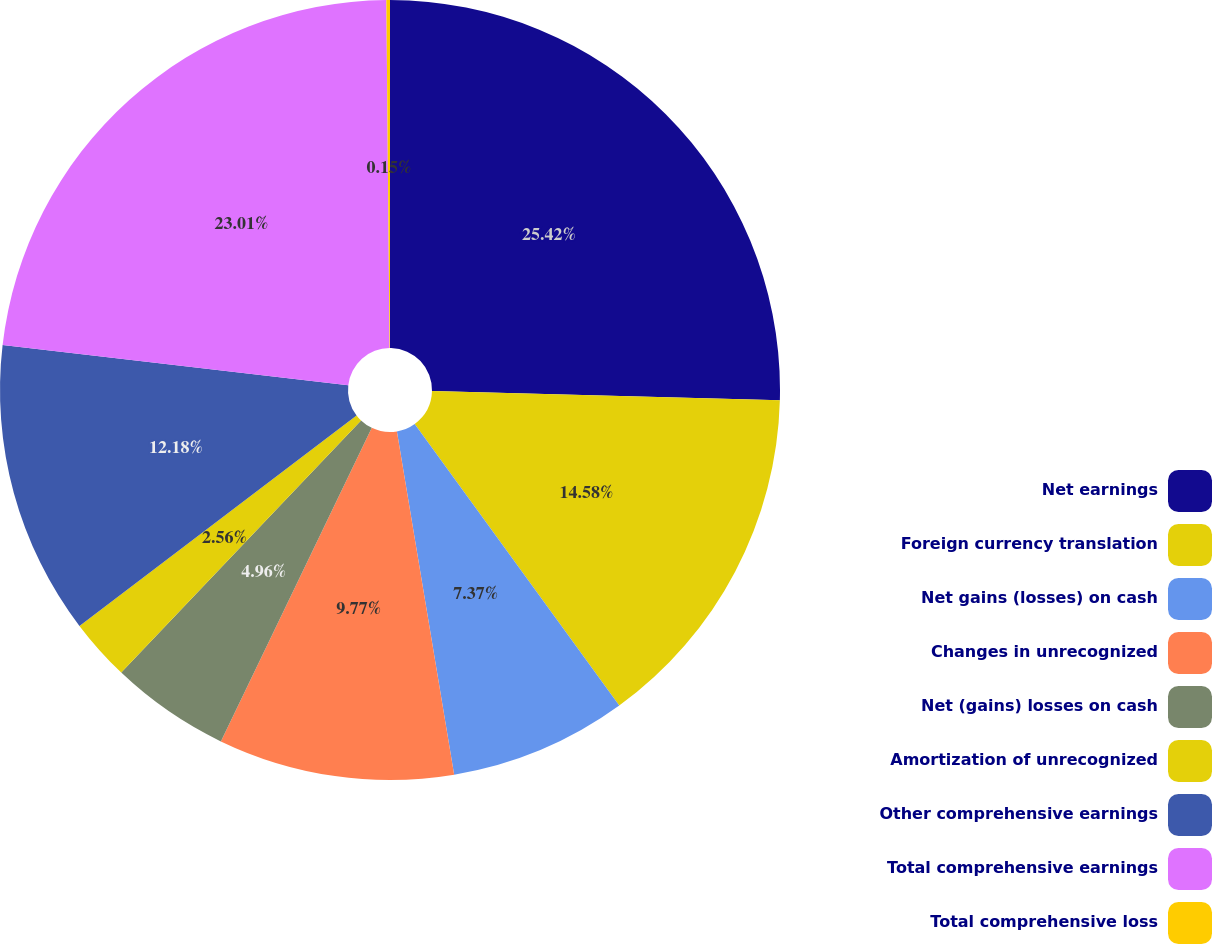Convert chart to OTSL. <chart><loc_0><loc_0><loc_500><loc_500><pie_chart><fcel>Net earnings<fcel>Foreign currency translation<fcel>Net gains (losses) on cash<fcel>Changes in unrecognized<fcel>Net (gains) losses on cash<fcel>Amortization of unrecognized<fcel>Other comprehensive earnings<fcel>Total comprehensive earnings<fcel>Total comprehensive loss<nl><fcel>25.42%<fcel>14.58%<fcel>7.37%<fcel>9.77%<fcel>4.96%<fcel>2.56%<fcel>12.18%<fcel>23.01%<fcel>0.15%<nl></chart> 